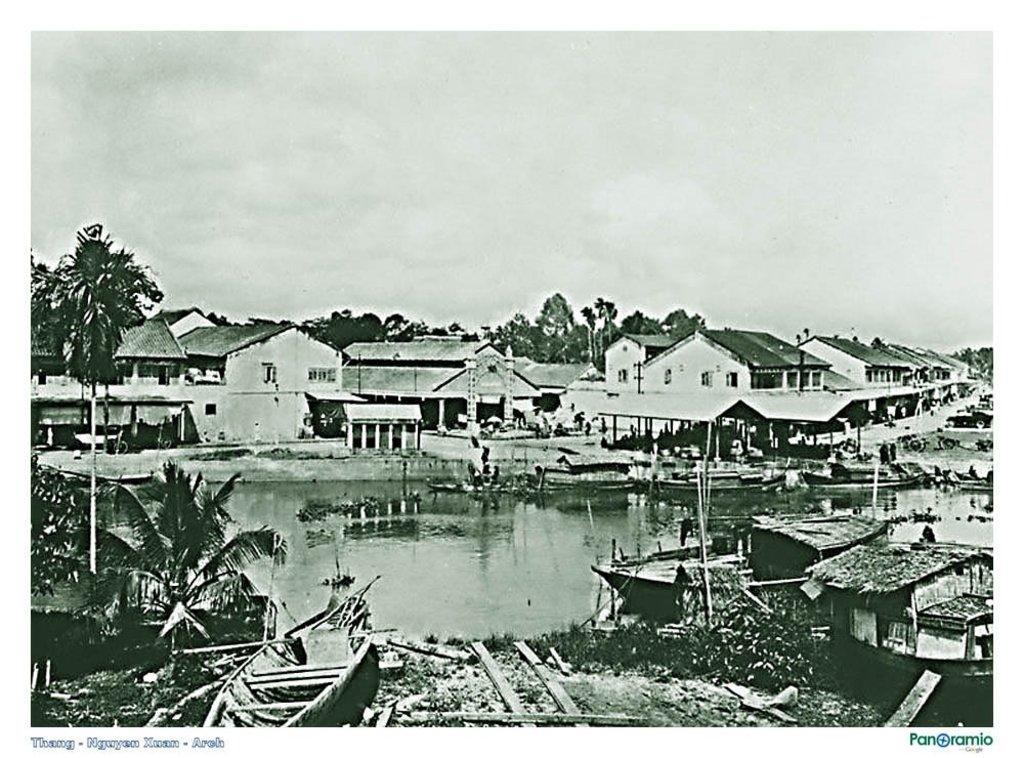Describe this image in one or two sentences. This is black and white picture where we can see a lake. Behind the lake buildings and trees are present. the sky is full of clouds. Bottom of the image boats are there. 